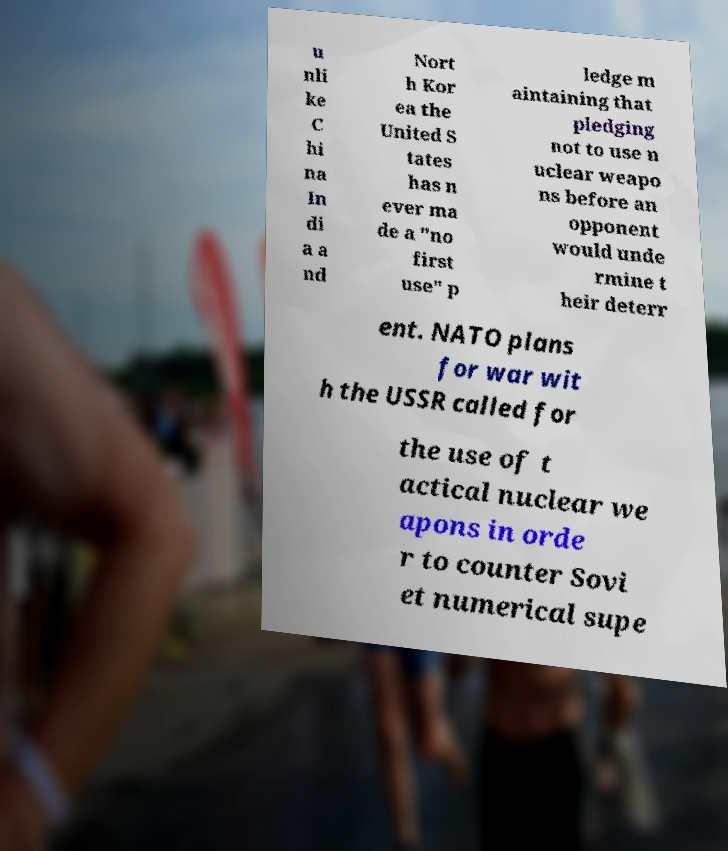Please read and relay the text visible in this image. What does it say? u nli ke C hi na In di a a nd Nort h Kor ea the United S tates has n ever ma de a "no first use" p ledge m aintaining that pledging not to use n uclear weapo ns before an opponent would unde rmine t heir deterr ent. NATO plans for war wit h the USSR called for the use of t actical nuclear we apons in orde r to counter Sovi et numerical supe 